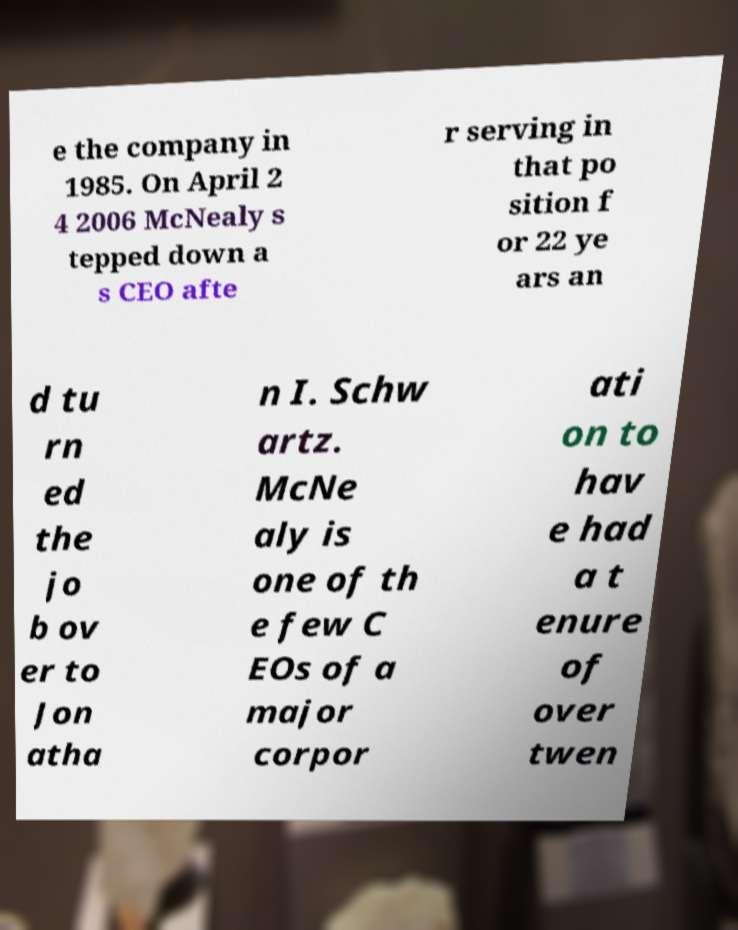Could you assist in decoding the text presented in this image and type it out clearly? e the company in 1985. On April 2 4 2006 McNealy s tepped down a s CEO afte r serving in that po sition f or 22 ye ars an d tu rn ed the jo b ov er to Jon atha n I. Schw artz. McNe aly is one of th e few C EOs of a major corpor ati on to hav e had a t enure of over twen 